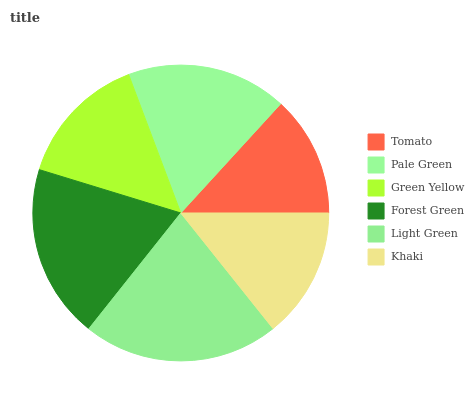Is Tomato the minimum?
Answer yes or no. Yes. Is Light Green the maximum?
Answer yes or no. Yes. Is Pale Green the minimum?
Answer yes or no. No. Is Pale Green the maximum?
Answer yes or no. No. Is Pale Green greater than Tomato?
Answer yes or no. Yes. Is Tomato less than Pale Green?
Answer yes or no. Yes. Is Tomato greater than Pale Green?
Answer yes or no. No. Is Pale Green less than Tomato?
Answer yes or no. No. Is Pale Green the high median?
Answer yes or no. Yes. Is Green Yellow the low median?
Answer yes or no. Yes. Is Tomato the high median?
Answer yes or no. No. Is Light Green the low median?
Answer yes or no. No. 